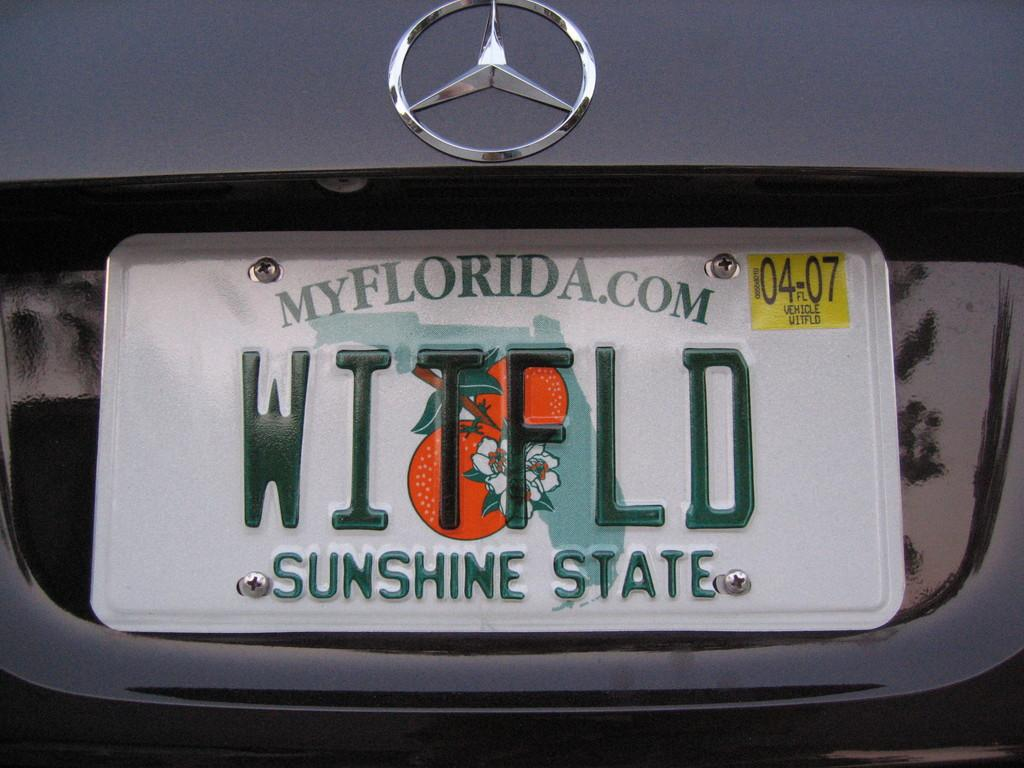Provide a one-sentence caption for the provided image. A Mercedes has a Florida license plate that says "sunshine state" at the bottom. 